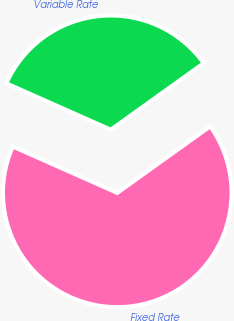<chart> <loc_0><loc_0><loc_500><loc_500><pie_chart><fcel>Fixed Rate<fcel>Variable Rate<nl><fcel>66.54%<fcel>33.46%<nl></chart> 